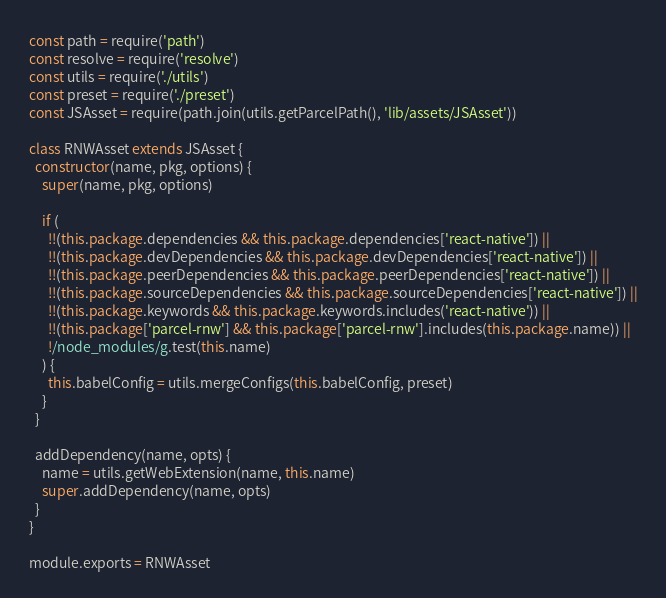Convert code to text. <code><loc_0><loc_0><loc_500><loc_500><_JavaScript_>const path = require('path')
const resolve = require('resolve')
const utils = require('./utils')
const preset = require('./preset')
const JSAsset = require(path.join(utils.getParcelPath(), 'lib/assets/JSAsset'))

class RNWAsset extends JSAsset {
  constructor(name, pkg, options) {
    super(name, pkg, options)

    if (
      !!(this.package.dependencies && this.package.dependencies['react-native']) ||
      !!(this.package.devDependencies && this.package.devDependencies['react-native']) ||
      !!(this.package.peerDependencies && this.package.peerDependencies['react-native']) ||
      !!(this.package.sourceDependencies && this.package.sourceDependencies['react-native']) ||
      !!(this.package.keywords && this.package.keywords.includes('react-native')) ||
      !!(this.package['parcel-rnw'] && this.package['parcel-rnw'].includes(this.package.name)) ||
      !/node_modules/g.test(this.name)
    ) {
      this.babelConfig = utils.mergeConfigs(this.babelConfig, preset)
    }
  }

  addDependency(name, opts) {
    name = utils.getWebExtension(name, this.name)
    super.addDependency(name, opts)
  }
}

module.exports = RNWAsset
</code> 